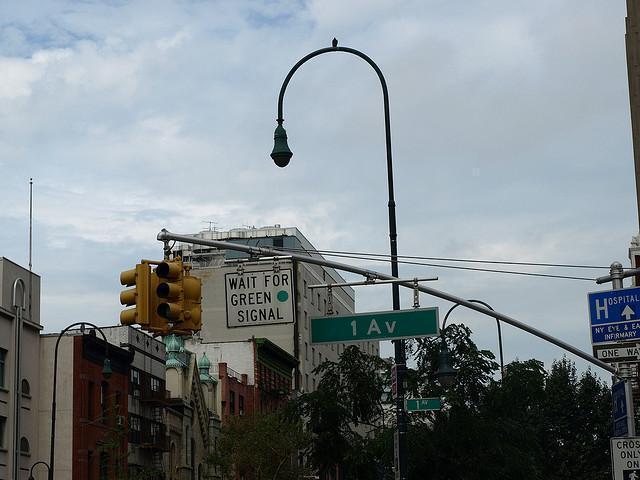What kind of environment is this?
Make your selection and explain in format: 'Answer: answer
Rationale: rationale.'
Options: Countryside, mountain vista, rural, urban. Answer: urban.
Rationale: There are traffic lights, buildings, and hospitals in this environment. there are no mountains. 